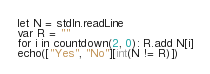Convert code to text. <code><loc_0><loc_0><loc_500><loc_500><_Nim_>let N = stdIn.readLine
var R = ""
for i in countdown(2, 0): R.add N[i]
echo(["Yes", "No"][int(N != R)])
</code> 